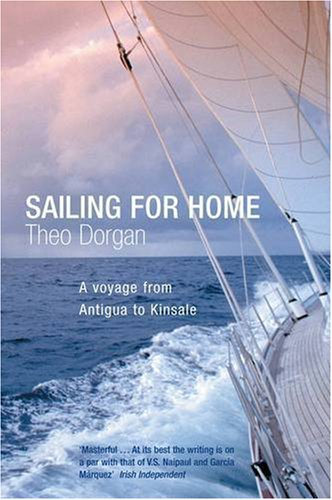How might the weather conditions depicted influence the narrative or themes of the book? The turbulent weather and formidable clouds suggest themes of resilience, challenge, and perhaps moments of introspection and existential contemplation, likely mirroring the psychological and physical experiences during the voyage. 